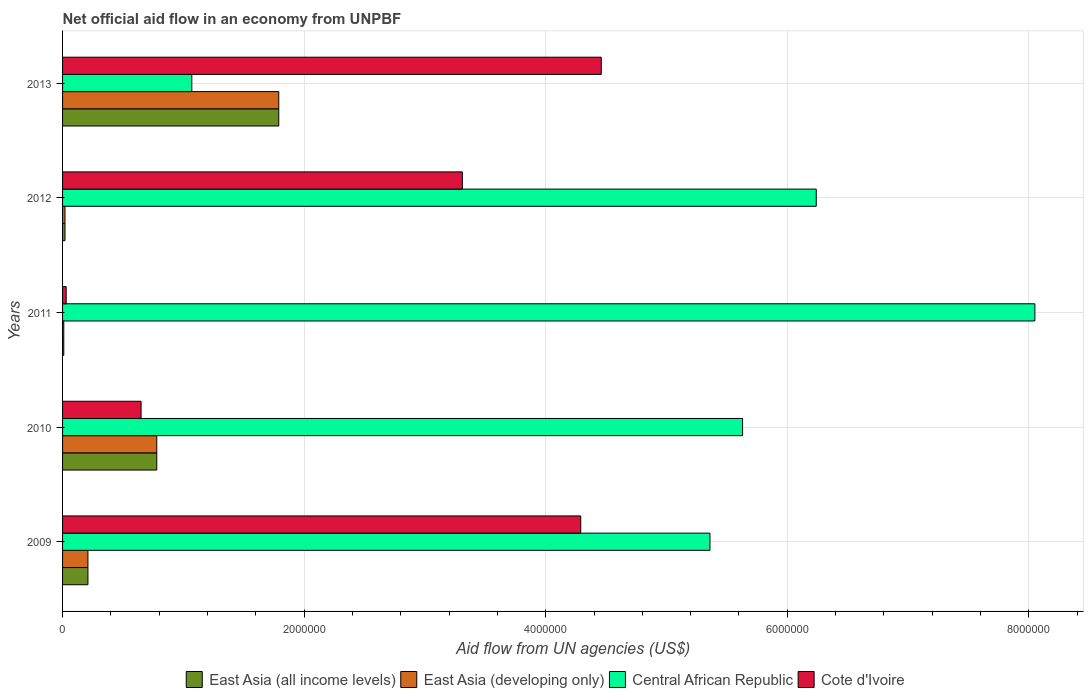How many different coloured bars are there?
Offer a very short reply. 4. How many groups of bars are there?
Give a very brief answer. 5. Are the number of bars per tick equal to the number of legend labels?
Keep it short and to the point. Yes. Are the number of bars on each tick of the Y-axis equal?
Offer a terse response. Yes. What is the label of the 4th group of bars from the top?
Ensure brevity in your answer.  2010. What is the net official aid flow in East Asia (all income levels) in 2012?
Your answer should be compact. 2.00e+04. Across all years, what is the maximum net official aid flow in East Asia (developing only)?
Your response must be concise. 1.79e+06. Across all years, what is the minimum net official aid flow in Central African Republic?
Ensure brevity in your answer.  1.07e+06. In which year was the net official aid flow in Cote d'Ivoire minimum?
Your response must be concise. 2011. What is the total net official aid flow in Central African Republic in the graph?
Provide a succinct answer. 2.64e+07. What is the difference between the net official aid flow in Cote d'Ivoire in 2011 and that in 2013?
Give a very brief answer. -4.43e+06. What is the difference between the net official aid flow in Cote d'Ivoire in 2010 and the net official aid flow in East Asia (developing only) in 2012?
Give a very brief answer. 6.30e+05. What is the average net official aid flow in Central African Republic per year?
Make the answer very short. 5.27e+06. In the year 2013, what is the difference between the net official aid flow in East Asia (all income levels) and net official aid flow in Cote d'Ivoire?
Offer a very short reply. -2.67e+06. In how many years, is the net official aid flow in East Asia (developing only) greater than 400000 US$?
Offer a very short reply. 2. What is the ratio of the net official aid flow in Central African Republic in 2010 to that in 2011?
Ensure brevity in your answer.  0.7. What is the difference between the highest and the second highest net official aid flow in East Asia (all income levels)?
Make the answer very short. 1.01e+06. What is the difference between the highest and the lowest net official aid flow in Cote d'Ivoire?
Offer a very short reply. 4.43e+06. In how many years, is the net official aid flow in East Asia (developing only) greater than the average net official aid flow in East Asia (developing only) taken over all years?
Provide a succinct answer. 2. Is the sum of the net official aid flow in Cote d'Ivoire in 2009 and 2012 greater than the maximum net official aid flow in East Asia (all income levels) across all years?
Give a very brief answer. Yes. What does the 4th bar from the top in 2010 represents?
Provide a succinct answer. East Asia (all income levels). What does the 1st bar from the bottom in 2012 represents?
Provide a succinct answer. East Asia (all income levels). Are all the bars in the graph horizontal?
Ensure brevity in your answer.  Yes. How many years are there in the graph?
Offer a very short reply. 5. Where does the legend appear in the graph?
Offer a terse response. Bottom center. How are the legend labels stacked?
Offer a very short reply. Horizontal. What is the title of the graph?
Offer a very short reply. Net official aid flow in an economy from UNPBF. Does "Caribbean small states" appear as one of the legend labels in the graph?
Offer a very short reply. No. What is the label or title of the X-axis?
Make the answer very short. Aid flow from UN agencies (US$). What is the label or title of the Y-axis?
Offer a very short reply. Years. What is the Aid flow from UN agencies (US$) in East Asia (all income levels) in 2009?
Provide a short and direct response. 2.10e+05. What is the Aid flow from UN agencies (US$) of Central African Republic in 2009?
Your response must be concise. 5.36e+06. What is the Aid flow from UN agencies (US$) in Cote d'Ivoire in 2009?
Provide a short and direct response. 4.29e+06. What is the Aid flow from UN agencies (US$) of East Asia (all income levels) in 2010?
Provide a short and direct response. 7.80e+05. What is the Aid flow from UN agencies (US$) in East Asia (developing only) in 2010?
Keep it short and to the point. 7.80e+05. What is the Aid flow from UN agencies (US$) in Central African Republic in 2010?
Keep it short and to the point. 5.63e+06. What is the Aid flow from UN agencies (US$) in Cote d'Ivoire in 2010?
Make the answer very short. 6.50e+05. What is the Aid flow from UN agencies (US$) of East Asia (all income levels) in 2011?
Offer a terse response. 10000. What is the Aid flow from UN agencies (US$) in East Asia (developing only) in 2011?
Your answer should be compact. 10000. What is the Aid flow from UN agencies (US$) in Central African Republic in 2011?
Your response must be concise. 8.05e+06. What is the Aid flow from UN agencies (US$) in Cote d'Ivoire in 2011?
Your answer should be very brief. 3.00e+04. What is the Aid flow from UN agencies (US$) of East Asia (all income levels) in 2012?
Your answer should be very brief. 2.00e+04. What is the Aid flow from UN agencies (US$) of Central African Republic in 2012?
Offer a terse response. 6.24e+06. What is the Aid flow from UN agencies (US$) of Cote d'Ivoire in 2012?
Your response must be concise. 3.31e+06. What is the Aid flow from UN agencies (US$) of East Asia (all income levels) in 2013?
Offer a terse response. 1.79e+06. What is the Aid flow from UN agencies (US$) in East Asia (developing only) in 2013?
Provide a succinct answer. 1.79e+06. What is the Aid flow from UN agencies (US$) of Central African Republic in 2013?
Your answer should be compact. 1.07e+06. What is the Aid flow from UN agencies (US$) of Cote d'Ivoire in 2013?
Your response must be concise. 4.46e+06. Across all years, what is the maximum Aid flow from UN agencies (US$) in East Asia (all income levels)?
Your answer should be compact. 1.79e+06. Across all years, what is the maximum Aid flow from UN agencies (US$) in East Asia (developing only)?
Keep it short and to the point. 1.79e+06. Across all years, what is the maximum Aid flow from UN agencies (US$) of Central African Republic?
Offer a terse response. 8.05e+06. Across all years, what is the maximum Aid flow from UN agencies (US$) of Cote d'Ivoire?
Provide a short and direct response. 4.46e+06. Across all years, what is the minimum Aid flow from UN agencies (US$) in East Asia (developing only)?
Your response must be concise. 10000. Across all years, what is the minimum Aid flow from UN agencies (US$) of Central African Republic?
Provide a short and direct response. 1.07e+06. What is the total Aid flow from UN agencies (US$) in East Asia (all income levels) in the graph?
Give a very brief answer. 2.81e+06. What is the total Aid flow from UN agencies (US$) in East Asia (developing only) in the graph?
Provide a succinct answer. 2.81e+06. What is the total Aid flow from UN agencies (US$) of Central African Republic in the graph?
Provide a short and direct response. 2.64e+07. What is the total Aid flow from UN agencies (US$) of Cote d'Ivoire in the graph?
Provide a succinct answer. 1.27e+07. What is the difference between the Aid flow from UN agencies (US$) in East Asia (all income levels) in 2009 and that in 2010?
Offer a very short reply. -5.70e+05. What is the difference between the Aid flow from UN agencies (US$) of East Asia (developing only) in 2009 and that in 2010?
Your answer should be very brief. -5.70e+05. What is the difference between the Aid flow from UN agencies (US$) of Central African Republic in 2009 and that in 2010?
Provide a succinct answer. -2.70e+05. What is the difference between the Aid flow from UN agencies (US$) in Cote d'Ivoire in 2009 and that in 2010?
Give a very brief answer. 3.64e+06. What is the difference between the Aid flow from UN agencies (US$) of East Asia (all income levels) in 2009 and that in 2011?
Provide a short and direct response. 2.00e+05. What is the difference between the Aid flow from UN agencies (US$) in East Asia (developing only) in 2009 and that in 2011?
Your answer should be very brief. 2.00e+05. What is the difference between the Aid flow from UN agencies (US$) of Central African Republic in 2009 and that in 2011?
Provide a short and direct response. -2.69e+06. What is the difference between the Aid flow from UN agencies (US$) in Cote d'Ivoire in 2009 and that in 2011?
Provide a short and direct response. 4.26e+06. What is the difference between the Aid flow from UN agencies (US$) of East Asia (developing only) in 2009 and that in 2012?
Make the answer very short. 1.90e+05. What is the difference between the Aid flow from UN agencies (US$) in Central African Republic in 2009 and that in 2012?
Your answer should be compact. -8.80e+05. What is the difference between the Aid flow from UN agencies (US$) of Cote d'Ivoire in 2009 and that in 2012?
Offer a terse response. 9.80e+05. What is the difference between the Aid flow from UN agencies (US$) of East Asia (all income levels) in 2009 and that in 2013?
Give a very brief answer. -1.58e+06. What is the difference between the Aid flow from UN agencies (US$) of East Asia (developing only) in 2009 and that in 2013?
Your answer should be compact. -1.58e+06. What is the difference between the Aid flow from UN agencies (US$) of Central African Republic in 2009 and that in 2013?
Make the answer very short. 4.29e+06. What is the difference between the Aid flow from UN agencies (US$) of East Asia (all income levels) in 2010 and that in 2011?
Keep it short and to the point. 7.70e+05. What is the difference between the Aid flow from UN agencies (US$) in East Asia (developing only) in 2010 and that in 2011?
Ensure brevity in your answer.  7.70e+05. What is the difference between the Aid flow from UN agencies (US$) in Central African Republic in 2010 and that in 2011?
Give a very brief answer. -2.42e+06. What is the difference between the Aid flow from UN agencies (US$) of Cote d'Ivoire in 2010 and that in 2011?
Provide a short and direct response. 6.20e+05. What is the difference between the Aid flow from UN agencies (US$) in East Asia (all income levels) in 2010 and that in 2012?
Keep it short and to the point. 7.60e+05. What is the difference between the Aid flow from UN agencies (US$) in East Asia (developing only) in 2010 and that in 2012?
Provide a succinct answer. 7.60e+05. What is the difference between the Aid flow from UN agencies (US$) in Central African Republic in 2010 and that in 2012?
Provide a short and direct response. -6.10e+05. What is the difference between the Aid flow from UN agencies (US$) of Cote d'Ivoire in 2010 and that in 2012?
Keep it short and to the point. -2.66e+06. What is the difference between the Aid flow from UN agencies (US$) of East Asia (all income levels) in 2010 and that in 2013?
Your answer should be compact. -1.01e+06. What is the difference between the Aid flow from UN agencies (US$) in East Asia (developing only) in 2010 and that in 2013?
Give a very brief answer. -1.01e+06. What is the difference between the Aid flow from UN agencies (US$) of Central African Republic in 2010 and that in 2013?
Your answer should be compact. 4.56e+06. What is the difference between the Aid flow from UN agencies (US$) of Cote d'Ivoire in 2010 and that in 2013?
Ensure brevity in your answer.  -3.81e+06. What is the difference between the Aid flow from UN agencies (US$) in East Asia (developing only) in 2011 and that in 2012?
Offer a very short reply. -10000. What is the difference between the Aid flow from UN agencies (US$) in Central African Republic in 2011 and that in 2012?
Your response must be concise. 1.81e+06. What is the difference between the Aid flow from UN agencies (US$) of Cote d'Ivoire in 2011 and that in 2012?
Provide a short and direct response. -3.28e+06. What is the difference between the Aid flow from UN agencies (US$) in East Asia (all income levels) in 2011 and that in 2013?
Your answer should be compact. -1.78e+06. What is the difference between the Aid flow from UN agencies (US$) of East Asia (developing only) in 2011 and that in 2013?
Provide a short and direct response. -1.78e+06. What is the difference between the Aid flow from UN agencies (US$) in Central African Republic in 2011 and that in 2013?
Offer a very short reply. 6.98e+06. What is the difference between the Aid flow from UN agencies (US$) in Cote d'Ivoire in 2011 and that in 2013?
Your answer should be very brief. -4.43e+06. What is the difference between the Aid flow from UN agencies (US$) of East Asia (all income levels) in 2012 and that in 2013?
Offer a terse response. -1.77e+06. What is the difference between the Aid flow from UN agencies (US$) in East Asia (developing only) in 2012 and that in 2013?
Offer a very short reply. -1.77e+06. What is the difference between the Aid flow from UN agencies (US$) of Central African Republic in 2012 and that in 2013?
Offer a terse response. 5.17e+06. What is the difference between the Aid flow from UN agencies (US$) in Cote d'Ivoire in 2012 and that in 2013?
Offer a terse response. -1.15e+06. What is the difference between the Aid flow from UN agencies (US$) in East Asia (all income levels) in 2009 and the Aid flow from UN agencies (US$) in East Asia (developing only) in 2010?
Provide a short and direct response. -5.70e+05. What is the difference between the Aid flow from UN agencies (US$) in East Asia (all income levels) in 2009 and the Aid flow from UN agencies (US$) in Central African Republic in 2010?
Provide a succinct answer. -5.42e+06. What is the difference between the Aid flow from UN agencies (US$) of East Asia (all income levels) in 2009 and the Aid flow from UN agencies (US$) of Cote d'Ivoire in 2010?
Offer a very short reply. -4.40e+05. What is the difference between the Aid flow from UN agencies (US$) of East Asia (developing only) in 2009 and the Aid flow from UN agencies (US$) of Central African Republic in 2010?
Your answer should be compact. -5.42e+06. What is the difference between the Aid flow from UN agencies (US$) of East Asia (developing only) in 2009 and the Aid flow from UN agencies (US$) of Cote d'Ivoire in 2010?
Keep it short and to the point. -4.40e+05. What is the difference between the Aid flow from UN agencies (US$) of Central African Republic in 2009 and the Aid flow from UN agencies (US$) of Cote d'Ivoire in 2010?
Provide a succinct answer. 4.71e+06. What is the difference between the Aid flow from UN agencies (US$) of East Asia (all income levels) in 2009 and the Aid flow from UN agencies (US$) of East Asia (developing only) in 2011?
Provide a short and direct response. 2.00e+05. What is the difference between the Aid flow from UN agencies (US$) in East Asia (all income levels) in 2009 and the Aid flow from UN agencies (US$) in Central African Republic in 2011?
Your answer should be very brief. -7.84e+06. What is the difference between the Aid flow from UN agencies (US$) in East Asia (all income levels) in 2009 and the Aid flow from UN agencies (US$) in Cote d'Ivoire in 2011?
Offer a very short reply. 1.80e+05. What is the difference between the Aid flow from UN agencies (US$) of East Asia (developing only) in 2009 and the Aid flow from UN agencies (US$) of Central African Republic in 2011?
Ensure brevity in your answer.  -7.84e+06. What is the difference between the Aid flow from UN agencies (US$) in Central African Republic in 2009 and the Aid flow from UN agencies (US$) in Cote d'Ivoire in 2011?
Give a very brief answer. 5.33e+06. What is the difference between the Aid flow from UN agencies (US$) in East Asia (all income levels) in 2009 and the Aid flow from UN agencies (US$) in Central African Republic in 2012?
Offer a very short reply. -6.03e+06. What is the difference between the Aid flow from UN agencies (US$) in East Asia (all income levels) in 2009 and the Aid flow from UN agencies (US$) in Cote d'Ivoire in 2012?
Your answer should be compact. -3.10e+06. What is the difference between the Aid flow from UN agencies (US$) in East Asia (developing only) in 2009 and the Aid flow from UN agencies (US$) in Central African Republic in 2012?
Offer a terse response. -6.03e+06. What is the difference between the Aid flow from UN agencies (US$) of East Asia (developing only) in 2009 and the Aid flow from UN agencies (US$) of Cote d'Ivoire in 2012?
Your answer should be very brief. -3.10e+06. What is the difference between the Aid flow from UN agencies (US$) in Central African Republic in 2009 and the Aid flow from UN agencies (US$) in Cote d'Ivoire in 2012?
Provide a short and direct response. 2.05e+06. What is the difference between the Aid flow from UN agencies (US$) in East Asia (all income levels) in 2009 and the Aid flow from UN agencies (US$) in East Asia (developing only) in 2013?
Make the answer very short. -1.58e+06. What is the difference between the Aid flow from UN agencies (US$) of East Asia (all income levels) in 2009 and the Aid flow from UN agencies (US$) of Central African Republic in 2013?
Provide a succinct answer. -8.60e+05. What is the difference between the Aid flow from UN agencies (US$) of East Asia (all income levels) in 2009 and the Aid flow from UN agencies (US$) of Cote d'Ivoire in 2013?
Your answer should be compact. -4.25e+06. What is the difference between the Aid flow from UN agencies (US$) in East Asia (developing only) in 2009 and the Aid flow from UN agencies (US$) in Central African Republic in 2013?
Offer a terse response. -8.60e+05. What is the difference between the Aid flow from UN agencies (US$) in East Asia (developing only) in 2009 and the Aid flow from UN agencies (US$) in Cote d'Ivoire in 2013?
Your answer should be compact. -4.25e+06. What is the difference between the Aid flow from UN agencies (US$) of East Asia (all income levels) in 2010 and the Aid flow from UN agencies (US$) of East Asia (developing only) in 2011?
Your answer should be compact. 7.70e+05. What is the difference between the Aid flow from UN agencies (US$) of East Asia (all income levels) in 2010 and the Aid flow from UN agencies (US$) of Central African Republic in 2011?
Keep it short and to the point. -7.27e+06. What is the difference between the Aid flow from UN agencies (US$) in East Asia (all income levels) in 2010 and the Aid flow from UN agencies (US$) in Cote d'Ivoire in 2011?
Your answer should be compact. 7.50e+05. What is the difference between the Aid flow from UN agencies (US$) of East Asia (developing only) in 2010 and the Aid flow from UN agencies (US$) of Central African Republic in 2011?
Your response must be concise. -7.27e+06. What is the difference between the Aid flow from UN agencies (US$) in East Asia (developing only) in 2010 and the Aid flow from UN agencies (US$) in Cote d'Ivoire in 2011?
Offer a terse response. 7.50e+05. What is the difference between the Aid flow from UN agencies (US$) of Central African Republic in 2010 and the Aid flow from UN agencies (US$) of Cote d'Ivoire in 2011?
Keep it short and to the point. 5.60e+06. What is the difference between the Aid flow from UN agencies (US$) of East Asia (all income levels) in 2010 and the Aid flow from UN agencies (US$) of East Asia (developing only) in 2012?
Keep it short and to the point. 7.60e+05. What is the difference between the Aid flow from UN agencies (US$) of East Asia (all income levels) in 2010 and the Aid flow from UN agencies (US$) of Central African Republic in 2012?
Provide a short and direct response. -5.46e+06. What is the difference between the Aid flow from UN agencies (US$) in East Asia (all income levels) in 2010 and the Aid flow from UN agencies (US$) in Cote d'Ivoire in 2012?
Your answer should be very brief. -2.53e+06. What is the difference between the Aid flow from UN agencies (US$) in East Asia (developing only) in 2010 and the Aid flow from UN agencies (US$) in Central African Republic in 2012?
Provide a succinct answer. -5.46e+06. What is the difference between the Aid flow from UN agencies (US$) of East Asia (developing only) in 2010 and the Aid flow from UN agencies (US$) of Cote d'Ivoire in 2012?
Provide a succinct answer. -2.53e+06. What is the difference between the Aid flow from UN agencies (US$) of Central African Republic in 2010 and the Aid flow from UN agencies (US$) of Cote d'Ivoire in 2012?
Ensure brevity in your answer.  2.32e+06. What is the difference between the Aid flow from UN agencies (US$) of East Asia (all income levels) in 2010 and the Aid flow from UN agencies (US$) of East Asia (developing only) in 2013?
Your answer should be very brief. -1.01e+06. What is the difference between the Aid flow from UN agencies (US$) of East Asia (all income levels) in 2010 and the Aid flow from UN agencies (US$) of Cote d'Ivoire in 2013?
Keep it short and to the point. -3.68e+06. What is the difference between the Aid flow from UN agencies (US$) in East Asia (developing only) in 2010 and the Aid flow from UN agencies (US$) in Cote d'Ivoire in 2013?
Keep it short and to the point. -3.68e+06. What is the difference between the Aid flow from UN agencies (US$) of Central African Republic in 2010 and the Aid flow from UN agencies (US$) of Cote d'Ivoire in 2013?
Make the answer very short. 1.17e+06. What is the difference between the Aid flow from UN agencies (US$) of East Asia (all income levels) in 2011 and the Aid flow from UN agencies (US$) of Central African Republic in 2012?
Your response must be concise. -6.23e+06. What is the difference between the Aid flow from UN agencies (US$) of East Asia (all income levels) in 2011 and the Aid flow from UN agencies (US$) of Cote d'Ivoire in 2012?
Your answer should be compact. -3.30e+06. What is the difference between the Aid flow from UN agencies (US$) of East Asia (developing only) in 2011 and the Aid flow from UN agencies (US$) of Central African Republic in 2012?
Provide a short and direct response. -6.23e+06. What is the difference between the Aid flow from UN agencies (US$) in East Asia (developing only) in 2011 and the Aid flow from UN agencies (US$) in Cote d'Ivoire in 2012?
Offer a very short reply. -3.30e+06. What is the difference between the Aid flow from UN agencies (US$) in Central African Republic in 2011 and the Aid flow from UN agencies (US$) in Cote d'Ivoire in 2012?
Offer a very short reply. 4.74e+06. What is the difference between the Aid flow from UN agencies (US$) of East Asia (all income levels) in 2011 and the Aid flow from UN agencies (US$) of East Asia (developing only) in 2013?
Give a very brief answer. -1.78e+06. What is the difference between the Aid flow from UN agencies (US$) of East Asia (all income levels) in 2011 and the Aid flow from UN agencies (US$) of Central African Republic in 2013?
Your answer should be very brief. -1.06e+06. What is the difference between the Aid flow from UN agencies (US$) in East Asia (all income levels) in 2011 and the Aid flow from UN agencies (US$) in Cote d'Ivoire in 2013?
Provide a short and direct response. -4.45e+06. What is the difference between the Aid flow from UN agencies (US$) of East Asia (developing only) in 2011 and the Aid flow from UN agencies (US$) of Central African Republic in 2013?
Provide a short and direct response. -1.06e+06. What is the difference between the Aid flow from UN agencies (US$) of East Asia (developing only) in 2011 and the Aid flow from UN agencies (US$) of Cote d'Ivoire in 2013?
Your answer should be compact. -4.45e+06. What is the difference between the Aid flow from UN agencies (US$) in Central African Republic in 2011 and the Aid flow from UN agencies (US$) in Cote d'Ivoire in 2013?
Your response must be concise. 3.59e+06. What is the difference between the Aid flow from UN agencies (US$) of East Asia (all income levels) in 2012 and the Aid flow from UN agencies (US$) of East Asia (developing only) in 2013?
Offer a very short reply. -1.77e+06. What is the difference between the Aid flow from UN agencies (US$) of East Asia (all income levels) in 2012 and the Aid flow from UN agencies (US$) of Central African Republic in 2013?
Provide a succinct answer. -1.05e+06. What is the difference between the Aid flow from UN agencies (US$) in East Asia (all income levels) in 2012 and the Aid flow from UN agencies (US$) in Cote d'Ivoire in 2013?
Keep it short and to the point. -4.44e+06. What is the difference between the Aid flow from UN agencies (US$) of East Asia (developing only) in 2012 and the Aid flow from UN agencies (US$) of Central African Republic in 2013?
Your response must be concise. -1.05e+06. What is the difference between the Aid flow from UN agencies (US$) in East Asia (developing only) in 2012 and the Aid flow from UN agencies (US$) in Cote d'Ivoire in 2013?
Your answer should be very brief. -4.44e+06. What is the difference between the Aid flow from UN agencies (US$) in Central African Republic in 2012 and the Aid flow from UN agencies (US$) in Cote d'Ivoire in 2013?
Your answer should be compact. 1.78e+06. What is the average Aid flow from UN agencies (US$) in East Asia (all income levels) per year?
Keep it short and to the point. 5.62e+05. What is the average Aid flow from UN agencies (US$) in East Asia (developing only) per year?
Give a very brief answer. 5.62e+05. What is the average Aid flow from UN agencies (US$) in Central African Republic per year?
Provide a succinct answer. 5.27e+06. What is the average Aid flow from UN agencies (US$) in Cote d'Ivoire per year?
Make the answer very short. 2.55e+06. In the year 2009, what is the difference between the Aid flow from UN agencies (US$) of East Asia (all income levels) and Aid flow from UN agencies (US$) of East Asia (developing only)?
Offer a terse response. 0. In the year 2009, what is the difference between the Aid flow from UN agencies (US$) of East Asia (all income levels) and Aid flow from UN agencies (US$) of Central African Republic?
Provide a short and direct response. -5.15e+06. In the year 2009, what is the difference between the Aid flow from UN agencies (US$) of East Asia (all income levels) and Aid flow from UN agencies (US$) of Cote d'Ivoire?
Keep it short and to the point. -4.08e+06. In the year 2009, what is the difference between the Aid flow from UN agencies (US$) in East Asia (developing only) and Aid flow from UN agencies (US$) in Central African Republic?
Provide a succinct answer. -5.15e+06. In the year 2009, what is the difference between the Aid flow from UN agencies (US$) in East Asia (developing only) and Aid flow from UN agencies (US$) in Cote d'Ivoire?
Provide a short and direct response. -4.08e+06. In the year 2009, what is the difference between the Aid flow from UN agencies (US$) in Central African Republic and Aid flow from UN agencies (US$) in Cote d'Ivoire?
Give a very brief answer. 1.07e+06. In the year 2010, what is the difference between the Aid flow from UN agencies (US$) of East Asia (all income levels) and Aid flow from UN agencies (US$) of Central African Republic?
Make the answer very short. -4.85e+06. In the year 2010, what is the difference between the Aid flow from UN agencies (US$) of East Asia (developing only) and Aid flow from UN agencies (US$) of Central African Republic?
Keep it short and to the point. -4.85e+06. In the year 2010, what is the difference between the Aid flow from UN agencies (US$) of East Asia (developing only) and Aid flow from UN agencies (US$) of Cote d'Ivoire?
Provide a short and direct response. 1.30e+05. In the year 2010, what is the difference between the Aid flow from UN agencies (US$) of Central African Republic and Aid flow from UN agencies (US$) of Cote d'Ivoire?
Your answer should be compact. 4.98e+06. In the year 2011, what is the difference between the Aid flow from UN agencies (US$) of East Asia (all income levels) and Aid flow from UN agencies (US$) of East Asia (developing only)?
Offer a terse response. 0. In the year 2011, what is the difference between the Aid flow from UN agencies (US$) in East Asia (all income levels) and Aid flow from UN agencies (US$) in Central African Republic?
Your answer should be compact. -8.04e+06. In the year 2011, what is the difference between the Aid flow from UN agencies (US$) of East Asia (all income levels) and Aid flow from UN agencies (US$) of Cote d'Ivoire?
Provide a succinct answer. -2.00e+04. In the year 2011, what is the difference between the Aid flow from UN agencies (US$) of East Asia (developing only) and Aid flow from UN agencies (US$) of Central African Republic?
Ensure brevity in your answer.  -8.04e+06. In the year 2011, what is the difference between the Aid flow from UN agencies (US$) of Central African Republic and Aid flow from UN agencies (US$) of Cote d'Ivoire?
Offer a terse response. 8.02e+06. In the year 2012, what is the difference between the Aid flow from UN agencies (US$) of East Asia (all income levels) and Aid flow from UN agencies (US$) of East Asia (developing only)?
Your answer should be very brief. 0. In the year 2012, what is the difference between the Aid flow from UN agencies (US$) in East Asia (all income levels) and Aid flow from UN agencies (US$) in Central African Republic?
Keep it short and to the point. -6.22e+06. In the year 2012, what is the difference between the Aid flow from UN agencies (US$) in East Asia (all income levels) and Aid flow from UN agencies (US$) in Cote d'Ivoire?
Keep it short and to the point. -3.29e+06. In the year 2012, what is the difference between the Aid flow from UN agencies (US$) in East Asia (developing only) and Aid flow from UN agencies (US$) in Central African Republic?
Your answer should be very brief. -6.22e+06. In the year 2012, what is the difference between the Aid flow from UN agencies (US$) of East Asia (developing only) and Aid flow from UN agencies (US$) of Cote d'Ivoire?
Your answer should be very brief. -3.29e+06. In the year 2012, what is the difference between the Aid flow from UN agencies (US$) in Central African Republic and Aid flow from UN agencies (US$) in Cote d'Ivoire?
Offer a very short reply. 2.93e+06. In the year 2013, what is the difference between the Aid flow from UN agencies (US$) of East Asia (all income levels) and Aid flow from UN agencies (US$) of East Asia (developing only)?
Your answer should be very brief. 0. In the year 2013, what is the difference between the Aid flow from UN agencies (US$) of East Asia (all income levels) and Aid flow from UN agencies (US$) of Central African Republic?
Your response must be concise. 7.20e+05. In the year 2013, what is the difference between the Aid flow from UN agencies (US$) in East Asia (all income levels) and Aid flow from UN agencies (US$) in Cote d'Ivoire?
Provide a succinct answer. -2.67e+06. In the year 2013, what is the difference between the Aid flow from UN agencies (US$) in East Asia (developing only) and Aid flow from UN agencies (US$) in Central African Republic?
Offer a terse response. 7.20e+05. In the year 2013, what is the difference between the Aid flow from UN agencies (US$) of East Asia (developing only) and Aid flow from UN agencies (US$) of Cote d'Ivoire?
Your answer should be compact. -2.67e+06. In the year 2013, what is the difference between the Aid flow from UN agencies (US$) in Central African Republic and Aid flow from UN agencies (US$) in Cote d'Ivoire?
Make the answer very short. -3.39e+06. What is the ratio of the Aid flow from UN agencies (US$) of East Asia (all income levels) in 2009 to that in 2010?
Offer a terse response. 0.27. What is the ratio of the Aid flow from UN agencies (US$) of East Asia (developing only) in 2009 to that in 2010?
Your answer should be compact. 0.27. What is the ratio of the Aid flow from UN agencies (US$) in Cote d'Ivoire in 2009 to that in 2010?
Your response must be concise. 6.6. What is the ratio of the Aid flow from UN agencies (US$) of Central African Republic in 2009 to that in 2011?
Provide a short and direct response. 0.67. What is the ratio of the Aid flow from UN agencies (US$) of Cote d'Ivoire in 2009 to that in 2011?
Your answer should be very brief. 143. What is the ratio of the Aid flow from UN agencies (US$) of East Asia (all income levels) in 2009 to that in 2012?
Offer a very short reply. 10.5. What is the ratio of the Aid flow from UN agencies (US$) in East Asia (developing only) in 2009 to that in 2012?
Your answer should be compact. 10.5. What is the ratio of the Aid flow from UN agencies (US$) in Central African Republic in 2009 to that in 2012?
Keep it short and to the point. 0.86. What is the ratio of the Aid flow from UN agencies (US$) of Cote d'Ivoire in 2009 to that in 2012?
Make the answer very short. 1.3. What is the ratio of the Aid flow from UN agencies (US$) of East Asia (all income levels) in 2009 to that in 2013?
Provide a short and direct response. 0.12. What is the ratio of the Aid flow from UN agencies (US$) of East Asia (developing only) in 2009 to that in 2013?
Provide a succinct answer. 0.12. What is the ratio of the Aid flow from UN agencies (US$) in Central African Republic in 2009 to that in 2013?
Keep it short and to the point. 5.01. What is the ratio of the Aid flow from UN agencies (US$) of Cote d'Ivoire in 2009 to that in 2013?
Keep it short and to the point. 0.96. What is the ratio of the Aid flow from UN agencies (US$) of Central African Republic in 2010 to that in 2011?
Provide a succinct answer. 0.7. What is the ratio of the Aid flow from UN agencies (US$) of Cote d'Ivoire in 2010 to that in 2011?
Give a very brief answer. 21.67. What is the ratio of the Aid flow from UN agencies (US$) in Central African Republic in 2010 to that in 2012?
Keep it short and to the point. 0.9. What is the ratio of the Aid flow from UN agencies (US$) in Cote d'Ivoire in 2010 to that in 2012?
Offer a terse response. 0.2. What is the ratio of the Aid flow from UN agencies (US$) of East Asia (all income levels) in 2010 to that in 2013?
Provide a succinct answer. 0.44. What is the ratio of the Aid flow from UN agencies (US$) of East Asia (developing only) in 2010 to that in 2013?
Ensure brevity in your answer.  0.44. What is the ratio of the Aid flow from UN agencies (US$) in Central African Republic in 2010 to that in 2013?
Keep it short and to the point. 5.26. What is the ratio of the Aid flow from UN agencies (US$) in Cote d'Ivoire in 2010 to that in 2013?
Your answer should be very brief. 0.15. What is the ratio of the Aid flow from UN agencies (US$) of East Asia (all income levels) in 2011 to that in 2012?
Keep it short and to the point. 0.5. What is the ratio of the Aid flow from UN agencies (US$) in Central African Republic in 2011 to that in 2012?
Provide a succinct answer. 1.29. What is the ratio of the Aid flow from UN agencies (US$) of Cote d'Ivoire in 2011 to that in 2012?
Your answer should be very brief. 0.01. What is the ratio of the Aid flow from UN agencies (US$) of East Asia (all income levels) in 2011 to that in 2013?
Offer a very short reply. 0.01. What is the ratio of the Aid flow from UN agencies (US$) in East Asia (developing only) in 2011 to that in 2013?
Keep it short and to the point. 0.01. What is the ratio of the Aid flow from UN agencies (US$) in Central African Republic in 2011 to that in 2013?
Provide a short and direct response. 7.52. What is the ratio of the Aid flow from UN agencies (US$) of Cote d'Ivoire in 2011 to that in 2013?
Your answer should be compact. 0.01. What is the ratio of the Aid flow from UN agencies (US$) in East Asia (all income levels) in 2012 to that in 2013?
Offer a terse response. 0.01. What is the ratio of the Aid flow from UN agencies (US$) in East Asia (developing only) in 2012 to that in 2013?
Offer a terse response. 0.01. What is the ratio of the Aid flow from UN agencies (US$) in Central African Republic in 2012 to that in 2013?
Ensure brevity in your answer.  5.83. What is the ratio of the Aid flow from UN agencies (US$) in Cote d'Ivoire in 2012 to that in 2013?
Your answer should be compact. 0.74. What is the difference between the highest and the second highest Aid flow from UN agencies (US$) in East Asia (all income levels)?
Make the answer very short. 1.01e+06. What is the difference between the highest and the second highest Aid flow from UN agencies (US$) in East Asia (developing only)?
Your answer should be very brief. 1.01e+06. What is the difference between the highest and the second highest Aid flow from UN agencies (US$) of Central African Republic?
Your answer should be very brief. 1.81e+06. What is the difference between the highest and the lowest Aid flow from UN agencies (US$) in East Asia (all income levels)?
Give a very brief answer. 1.78e+06. What is the difference between the highest and the lowest Aid flow from UN agencies (US$) in East Asia (developing only)?
Offer a very short reply. 1.78e+06. What is the difference between the highest and the lowest Aid flow from UN agencies (US$) in Central African Republic?
Give a very brief answer. 6.98e+06. What is the difference between the highest and the lowest Aid flow from UN agencies (US$) in Cote d'Ivoire?
Your response must be concise. 4.43e+06. 